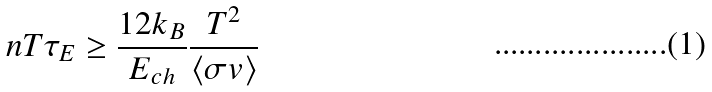<formula> <loc_0><loc_0><loc_500><loc_500>n T \tau _ { E } \geq \frac { 1 2 k _ { B } } { E _ { c h } } \frac { T ^ { 2 } } { \langle \sigma v \rangle }</formula> 